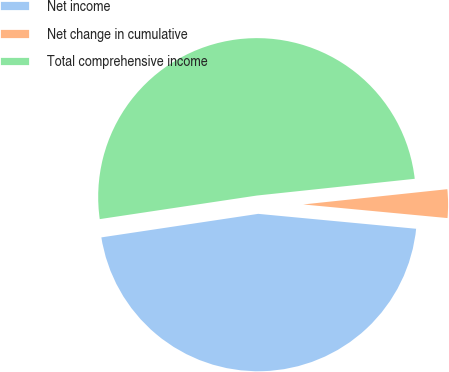Convert chart. <chart><loc_0><loc_0><loc_500><loc_500><pie_chart><fcel>Net income<fcel>Net change in cumulative<fcel>Total comprehensive income<nl><fcel>46.13%<fcel>3.18%<fcel>50.69%<nl></chart> 